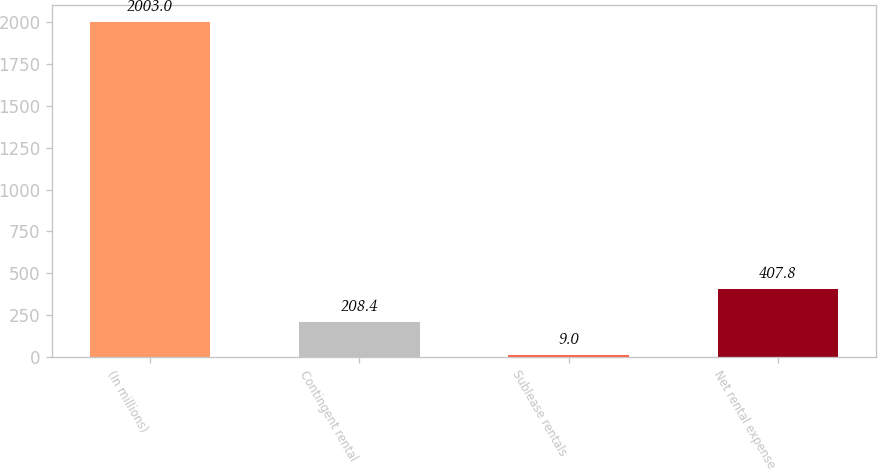Convert chart to OTSL. <chart><loc_0><loc_0><loc_500><loc_500><bar_chart><fcel>(In millions)<fcel>Contingent rental<fcel>Sublease rentals<fcel>Net rental expense<nl><fcel>2003<fcel>208.4<fcel>9<fcel>407.8<nl></chart> 